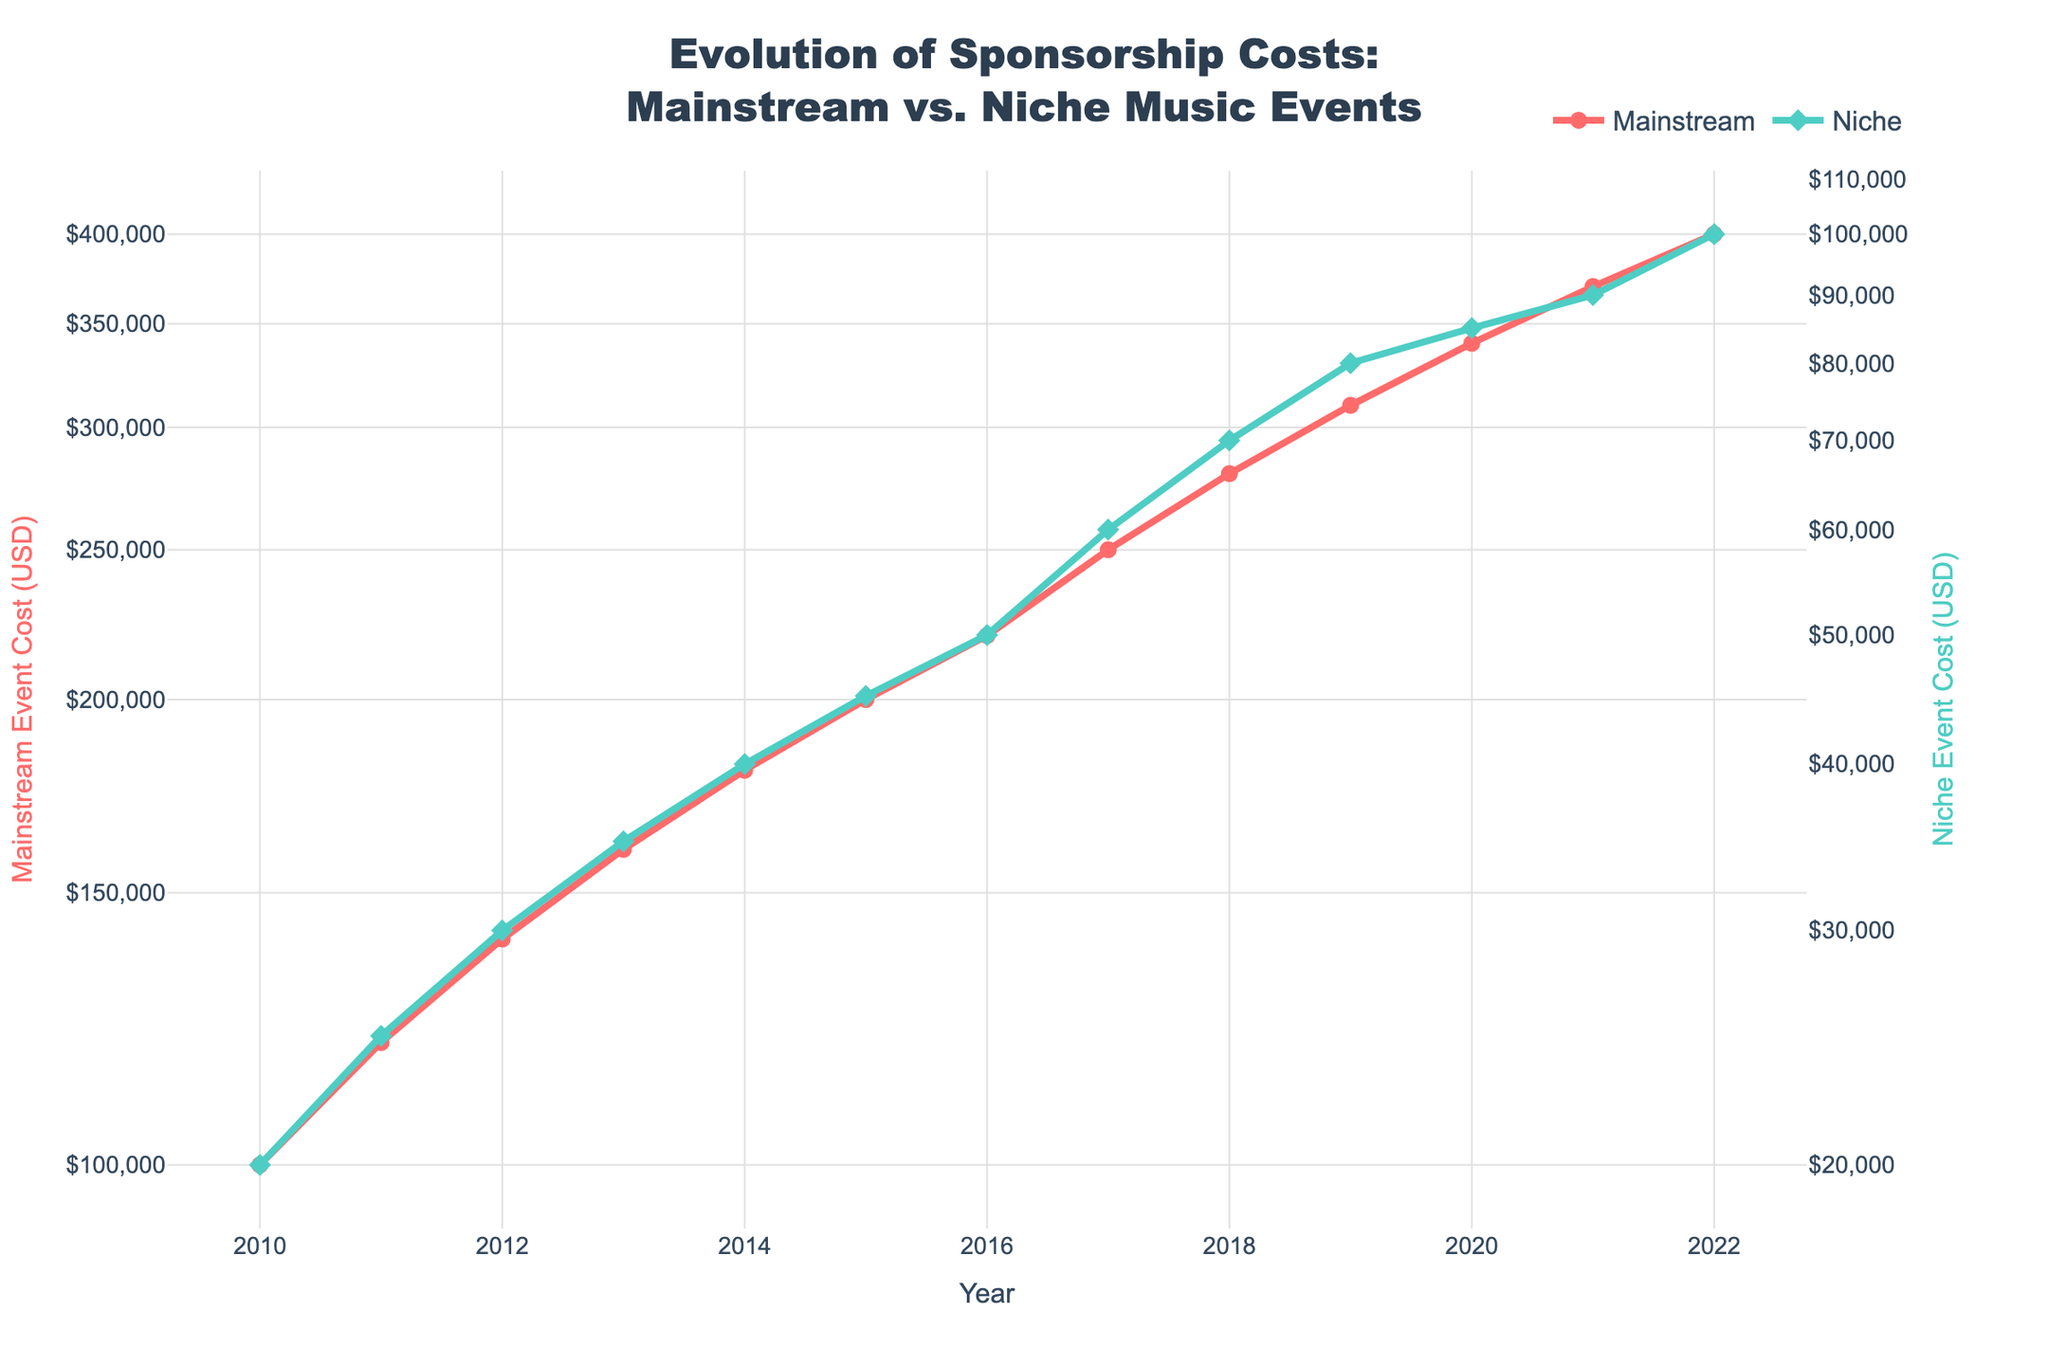What is the title of the plot? The title is usually located at the top center of the figure. It provides an overview of what the figure is about.
Answer: Evolution of Sponsorship Costs: Mainstream vs. Niche Music Events What color represents Mainstream event costs in the plot? Color is used to differentiate categories in the plot. In this figure, colors are assigned for ease of comparison.
Answer: Red What is the cost of sponsoring a Niche music event in 2022? Locate the data point for the year 2022 under the Niche category and read off the value on the y-axis.
Answer: $100,000 How many years are depicted in the plot? Count the number of years marked on the x-axis.
Answer: 13 years Which year saw the highest sponsorship cost for Mainstream events, and what was the cost? Identify the peak point of the Mainstream event line and note the corresponding year and cost value.
Answer: 2022, $400,000 By how much did the cost of sponsoring a Niche event increase from 2010 to 2022? Subtract the 2010 sponsorship cost for Niche events from the 2022 cost.
Answer: $80,000 Compared to Niche events, how much more did it cost to sponsor a Mainstream event in 2015? Find the costs for both event types in 2015 and subtract the Niche cost from the Mainstream cost.
Answer: $155,000 What is the general trend for sponsorship costs for both Mainstream and Niche events from 2010 to 2022? Look for the overall direction (upward, downward, or stagnant) in the lines for both categories.
Answer: Upward If the trend continues, what might be the estimated cost for a Mainstream event in 2023? Extrapolate the trend line for Mainstream events from previous data points to estimate the next value.
Answer: Approximately $420,000 How do the y-axes differ for Mainstream and Niche event costs, and why is this useful? Identify the scaling method used (logarithmic) and explain its purpose in this context.
Answer: Both y-axes use a logarithmic scale, which helps visualize vast differences in sponsorship costs between Mainstream and Niche events more clearly 